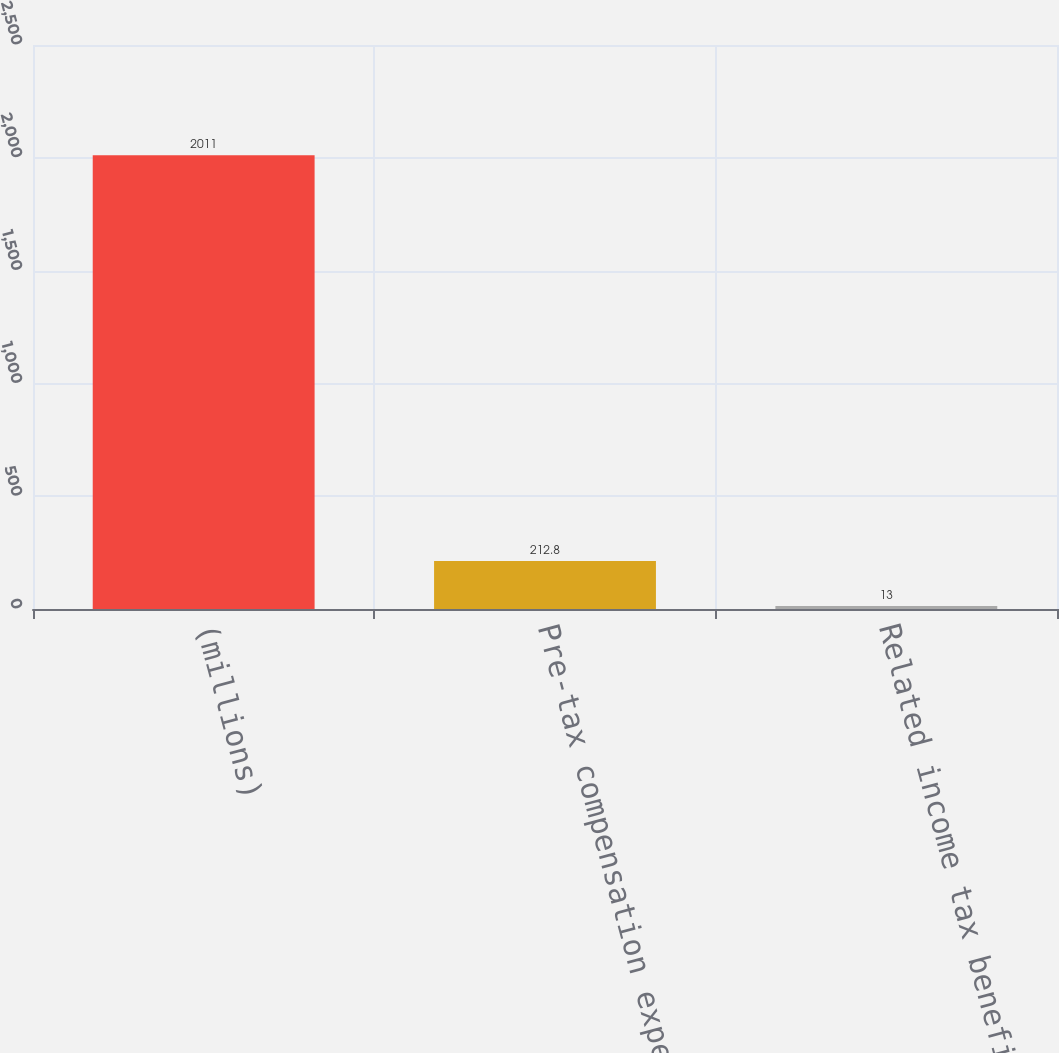Convert chart. <chart><loc_0><loc_0><loc_500><loc_500><bar_chart><fcel>(millions)<fcel>Pre-tax compensation expense<fcel>Related income tax benefit<nl><fcel>2011<fcel>212.8<fcel>13<nl></chart> 